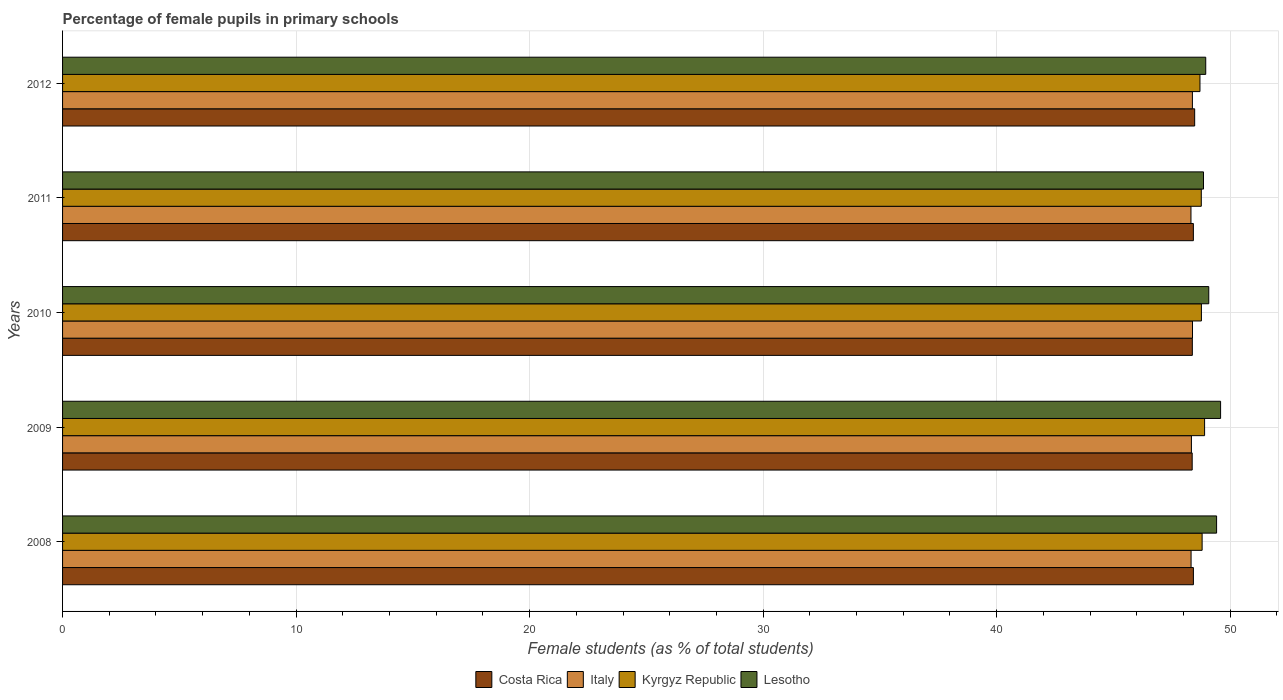How many different coloured bars are there?
Offer a terse response. 4. Are the number of bars on each tick of the Y-axis equal?
Provide a succinct answer. Yes. How many bars are there on the 2nd tick from the top?
Provide a short and direct response. 4. How many bars are there on the 3rd tick from the bottom?
Give a very brief answer. 4. What is the label of the 3rd group of bars from the top?
Your response must be concise. 2010. In how many cases, is the number of bars for a given year not equal to the number of legend labels?
Provide a succinct answer. 0. What is the percentage of female pupils in primary schools in Italy in 2011?
Keep it short and to the point. 48.32. Across all years, what is the maximum percentage of female pupils in primary schools in Costa Rica?
Provide a succinct answer. 48.48. Across all years, what is the minimum percentage of female pupils in primary schools in Lesotho?
Make the answer very short. 48.86. In which year was the percentage of female pupils in primary schools in Kyrgyz Republic maximum?
Your response must be concise. 2009. What is the total percentage of female pupils in primary schools in Lesotho in the graph?
Make the answer very short. 245.89. What is the difference between the percentage of female pupils in primary schools in Costa Rica in 2008 and that in 2011?
Your answer should be very brief. 0. What is the difference between the percentage of female pupils in primary schools in Kyrgyz Republic in 2010 and the percentage of female pupils in primary schools in Costa Rica in 2011?
Your answer should be very brief. 0.34. What is the average percentage of female pupils in primary schools in Costa Rica per year?
Ensure brevity in your answer.  48.41. In the year 2008, what is the difference between the percentage of female pupils in primary schools in Costa Rica and percentage of female pupils in primary schools in Lesotho?
Make the answer very short. -0.99. What is the ratio of the percentage of female pupils in primary schools in Italy in 2009 to that in 2012?
Offer a very short reply. 1. Is the percentage of female pupils in primary schools in Costa Rica in 2011 less than that in 2012?
Provide a short and direct response. Yes. Is the difference between the percentage of female pupils in primary schools in Costa Rica in 2009 and 2010 greater than the difference between the percentage of female pupils in primary schools in Lesotho in 2009 and 2010?
Ensure brevity in your answer.  No. What is the difference between the highest and the second highest percentage of female pupils in primary schools in Italy?
Make the answer very short. 0. What is the difference between the highest and the lowest percentage of female pupils in primary schools in Italy?
Your response must be concise. 0.07. What does the 1st bar from the bottom in 2010 represents?
Give a very brief answer. Costa Rica. Are all the bars in the graph horizontal?
Give a very brief answer. Yes. What is the difference between two consecutive major ticks on the X-axis?
Provide a succinct answer. 10. Does the graph contain any zero values?
Offer a very short reply. No. Where does the legend appear in the graph?
Your answer should be very brief. Bottom center. How are the legend labels stacked?
Offer a very short reply. Horizontal. What is the title of the graph?
Keep it short and to the point. Percentage of female pupils in primary schools. What is the label or title of the X-axis?
Ensure brevity in your answer.  Female students (as % of total students). What is the Female students (as % of total students) of Costa Rica in 2008?
Your answer should be compact. 48.42. What is the Female students (as % of total students) of Italy in 2008?
Make the answer very short. 48.32. What is the Female students (as % of total students) in Kyrgyz Republic in 2008?
Your response must be concise. 48.8. What is the Female students (as % of total students) in Lesotho in 2008?
Make the answer very short. 49.42. What is the Female students (as % of total students) of Costa Rica in 2009?
Ensure brevity in your answer.  48.37. What is the Female students (as % of total students) in Italy in 2009?
Your response must be concise. 48.34. What is the Female students (as % of total students) of Kyrgyz Republic in 2009?
Provide a succinct answer. 48.9. What is the Female students (as % of total students) of Lesotho in 2009?
Give a very brief answer. 49.59. What is the Female students (as % of total students) of Costa Rica in 2010?
Your answer should be compact. 48.38. What is the Female students (as % of total students) in Italy in 2010?
Offer a terse response. 48.38. What is the Female students (as % of total students) in Kyrgyz Republic in 2010?
Your response must be concise. 48.77. What is the Female students (as % of total students) of Lesotho in 2010?
Offer a terse response. 49.08. What is the Female students (as % of total students) of Costa Rica in 2011?
Ensure brevity in your answer.  48.42. What is the Female students (as % of total students) of Italy in 2011?
Ensure brevity in your answer.  48.32. What is the Female students (as % of total students) of Kyrgyz Republic in 2011?
Provide a succinct answer. 48.76. What is the Female students (as % of total students) of Lesotho in 2011?
Your response must be concise. 48.86. What is the Female students (as % of total students) in Costa Rica in 2012?
Make the answer very short. 48.48. What is the Female students (as % of total students) in Italy in 2012?
Keep it short and to the point. 48.38. What is the Female students (as % of total students) of Kyrgyz Republic in 2012?
Provide a succinct answer. 48.7. What is the Female students (as % of total students) of Lesotho in 2012?
Offer a very short reply. 48.95. Across all years, what is the maximum Female students (as % of total students) in Costa Rica?
Offer a very short reply. 48.48. Across all years, what is the maximum Female students (as % of total students) in Italy?
Your response must be concise. 48.38. Across all years, what is the maximum Female students (as % of total students) in Kyrgyz Republic?
Provide a succinct answer. 48.9. Across all years, what is the maximum Female students (as % of total students) of Lesotho?
Give a very brief answer. 49.59. Across all years, what is the minimum Female students (as % of total students) in Costa Rica?
Ensure brevity in your answer.  48.37. Across all years, what is the minimum Female students (as % of total students) of Italy?
Your answer should be compact. 48.32. Across all years, what is the minimum Female students (as % of total students) of Kyrgyz Republic?
Make the answer very short. 48.7. Across all years, what is the minimum Female students (as % of total students) of Lesotho?
Give a very brief answer. 48.86. What is the total Female students (as % of total students) of Costa Rica in the graph?
Offer a terse response. 242.07. What is the total Female students (as % of total students) of Italy in the graph?
Ensure brevity in your answer.  241.75. What is the total Female students (as % of total students) of Kyrgyz Republic in the graph?
Offer a very short reply. 243.93. What is the total Female students (as % of total students) in Lesotho in the graph?
Keep it short and to the point. 245.89. What is the difference between the Female students (as % of total students) of Costa Rica in 2008 and that in 2009?
Give a very brief answer. 0.05. What is the difference between the Female students (as % of total students) of Italy in 2008 and that in 2009?
Make the answer very short. -0.01. What is the difference between the Female students (as % of total students) in Kyrgyz Republic in 2008 and that in 2009?
Your response must be concise. -0.11. What is the difference between the Female students (as % of total students) of Lesotho in 2008 and that in 2009?
Your response must be concise. -0.17. What is the difference between the Female students (as % of total students) of Costa Rica in 2008 and that in 2010?
Ensure brevity in your answer.  0.05. What is the difference between the Female students (as % of total students) of Italy in 2008 and that in 2010?
Your response must be concise. -0.06. What is the difference between the Female students (as % of total students) of Kyrgyz Republic in 2008 and that in 2010?
Your answer should be compact. 0.03. What is the difference between the Female students (as % of total students) in Lesotho in 2008 and that in 2010?
Offer a terse response. 0.34. What is the difference between the Female students (as % of total students) of Costa Rica in 2008 and that in 2011?
Provide a short and direct response. 0. What is the difference between the Female students (as % of total students) of Italy in 2008 and that in 2011?
Provide a short and direct response. 0.01. What is the difference between the Female students (as % of total students) of Kyrgyz Republic in 2008 and that in 2011?
Your response must be concise. 0.04. What is the difference between the Female students (as % of total students) of Lesotho in 2008 and that in 2011?
Your answer should be compact. 0.56. What is the difference between the Female students (as % of total students) in Costa Rica in 2008 and that in 2012?
Provide a succinct answer. -0.05. What is the difference between the Female students (as % of total students) of Italy in 2008 and that in 2012?
Make the answer very short. -0.06. What is the difference between the Female students (as % of total students) in Kyrgyz Republic in 2008 and that in 2012?
Ensure brevity in your answer.  0.09. What is the difference between the Female students (as % of total students) of Lesotho in 2008 and that in 2012?
Give a very brief answer. 0.47. What is the difference between the Female students (as % of total students) in Costa Rica in 2009 and that in 2010?
Ensure brevity in your answer.  -0.01. What is the difference between the Female students (as % of total students) of Italy in 2009 and that in 2010?
Give a very brief answer. -0.05. What is the difference between the Female students (as % of total students) in Kyrgyz Republic in 2009 and that in 2010?
Your answer should be compact. 0.14. What is the difference between the Female students (as % of total students) in Lesotho in 2009 and that in 2010?
Your response must be concise. 0.51. What is the difference between the Female students (as % of total students) in Costa Rica in 2009 and that in 2011?
Your answer should be very brief. -0.05. What is the difference between the Female students (as % of total students) of Italy in 2009 and that in 2011?
Provide a short and direct response. 0.02. What is the difference between the Female students (as % of total students) in Kyrgyz Republic in 2009 and that in 2011?
Provide a short and direct response. 0.14. What is the difference between the Female students (as % of total students) of Lesotho in 2009 and that in 2011?
Keep it short and to the point. 0.73. What is the difference between the Female students (as % of total students) in Costa Rica in 2009 and that in 2012?
Offer a very short reply. -0.11. What is the difference between the Female students (as % of total students) of Italy in 2009 and that in 2012?
Make the answer very short. -0.04. What is the difference between the Female students (as % of total students) of Kyrgyz Republic in 2009 and that in 2012?
Your answer should be compact. 0.2. What is the difference between the Female students (as % of total students) in Lesotho in 2009 and that in 2012?
Your answer should be compact. 0.64. What is the difference between the Female students (as % of total students) of Costa Rica in 2010 and that in 2011?
Make the answer very short. -0.04. What is the difference between the Female students (as % of total students) in Italy in 2010 and that in 2011?
Your answer should be compact. 0.07. What is the difference between the Female students (as % of total students) in Kyrgyz Republic in 2010 and that in 2011?
Ensure brevity in your answer.  0.01. What is the difference between the Female students (as % of total students) in Lesotho in 2010 and that in 2011?
Offer a terse response. 0.23. What is the difference between the Female students (as % of total students) in Costa Rica in 2010 and that in 2012?
Offer a very short reply. -0.1. What is the difference between the Female students (as % of total students) in Italy in 2010 and that in 2012?
Your answer should be compact. 0. What is the difference between the Female students (as % of total students) in Kyrgyz Republic in 2010 and that in 2012?
Provide a succinct answer. 0.06. What is the difference between the Female students (as % of total students) of Lesotho in 2010 and that in 2012?
Keep it short and to the point. 0.13. What is the difference between the Female students (as % of total students) in Costa Rica in 2011 and that in 2012?
Provide a succinct answer. -0.06. What is the difference between the Female students (as % of total students) in Italy in 2011 and that in 2012?
Provide a succinct answer. -0.06. What is the difference between the Female students (as % of total students) of Kyrgyz Republic in 2011 and that in 2012?
Offer a terse response. 0.06. What is the difference between the Female students (as % of total students) in Lesotho in 2011 and that in 2012?
Provide a succinct answer. -0.1. What is the difference between the Female students (as % of total students) in Costa Rica in 2008 and the Female students (as % of total students) in Italy in 2009?
Your answer should be compact. 0.09. What is the difference between the Female students (as % of total students) in Costa Rica in 2008 and the Female students (as % of total students) in Kyrgyz Republic in 2009?
Ensure brevity in your answer.  -0.48. What is the difference between the Female students (as % of total students) in Costa Rica in 2008 and the Female students (as % of total students) in Lesotho in 2009?
Ensure brevity in your answer.  -1.16. What is the difference between the Female students (as % of total students) of Italy in 2008 and the Female students (as % of total students) of Kyrgyz Republic in 2009?
Ensure brevity in your answer.  -0.58. What is the difference between the Female students (as % of total students) of Italy in 2008 and the Female students (as % of total students) of Lesotho in 2009?
Your answer should be compact. -1.26. What is the difference between the Female students (as % of total students) of Kyrgyz Republic in 2008 and the Female students (as % of total students) of Lesotho in 2009?
Provide a succinct answer. -0.79. What is the difference between the Female students (as % of total students) in Costa Rica in 2008 and the Female students (as % of total students) in Italy in 2010?
Provide a short and direct response. 0.04. What is the difference between the Female students (as % of total students) in Costa Rica in 2008 and the Female students (as % of total students) in Kyrgyz Republic in 2010?
Offer a terse response. -0.34. What is the difference between the Female students (as % of total students) in Costa Rica in 2008 and the Female students (as % of total students) in Lesotho in 2010?
Keep it short and to the point. -0.66. What is the difference between the Female students (as % of total students) of Italy in 2008 and the Female students (as % of total students) of Kyrgyz Republic in 2010?
Give a very brief answer. -0.44. What is the difference between the Female students (as % of total students) in Italy in 2008 and the Female students (as % of total students) in Lesotho in 2010?
Give a very brief answer. -0.76. What is the difference between the Female students (as % of total students) in Kyrgyz Republic in 2008 and the Female students (as % of total students) in Lesotho in 2010?
Ensure brevity in your answer.  -0.28. What is the difference between the Female students (as % of total students) in Costa Rica in 2008 and the Female students (as % of total students) in Italy in 2011?
Provide a succinct answer. 0.1. What is the difference between the Female students (as % of total students) in Costa Rica in 2008 and the Female students (as % of total students) in Kyrgyz Republic in 2011?
Your response must be concise. -0.34. What is the difference between the Female students (as % of total students) of Costa Rica in 2008 and the Female students (as % of total students) of Lesotho in 2011?
Give a very brief answer. -0.43. What is the difference between the Female students (as % of total students) in Italy in 2008 and the Female students (as % of total students) in Kyrgyz Republic in 2011?
Your response must be concise. -0.44. What is the difference between the Female students (as % of total students) of Italy in 2008 and the Female students (as % of total students) of Lesotho in 2011?
Your response must be concise. -0.53. What is the difference between the Female students (as % of total students) in Kyrgyz Republic in 2008 and the Female students (as % of total students) in Lesotho in 2011?
Give a very brief answer. -0.06. What is the difference between the Female students (as % of total students) in Costa Rica in 2008 and the Female students (as % of total students) in Italy in 2012?
Provide a short and direct response. 0.04. What is the difference between the Female students (as % of total students) of Costa Rica in 2008 and the Female students (as % of total students) of Kyrgyz Republic in 2012?
Keep it short and to the point. -0.28. What is the difference between the Female students (as % of total students) in Costa Rica in 2008 and the Female students (as % of total students) in Lesotho in 2012?
Your response must be concise. -0.53. What is the difference between the Female students (as % of total students) of Italy in 2008 and the Female students (as % of total students) of Kyrgyz Republic in 2012?
Keep it short and to the point. -0.38. What is the difference between the Female students (as % of total students) in Italy in 2008 and the Female students (as % of total students) in Lesotho in 2012?
Offer a very short reply. -0.63. What is the difference between the Female students (as % of total students) in Kyrgyz Republic in 2008 and the Female students (as % of total students) in Lesotho in 2012?
Make the answer very short. -0.15. What is the difference between the Female students (as % of total students) in Costa Rica in 2009 and the Female students (as % of total students) in Italy in 2010?
Your answer should be very brief. -0.01. What is the difference between the Female students (as % of total students) of Costa Rica in 2009 and the Female students (as % of total students) of Kyrgyz Republic in 2010?
Provide a succinct answer. -0.4. What is the difference between the Female students (as % of total students) of Costa Rica in 2009 and the Female students (as % of total students) of Lesotho in 2010?
Give a very brief answer. -0.71. What is the difference between the Female students (as % of total students) of Italy in 2009 and the Female students (as % of total students) of Kyrgyz Republic in 2010?
Ensure brevity in your answer.  -0.43. What is the difference between the Female students (as % of total students) in Italy in 2009 and the Female students (as % of total students) in Lesotho in 2010?
Provide a succinct answer. -0.74. What is the difference between the Female students (as % of total students) in Kyrgyz Republic in 2009 and the Female students (as % of total students) in Lesotho in 2010?
Your response must be concise. -0.18. What is the difference between the Female students (as % of total students) in Costa Rica in 2009 and the Female students (as % of total students) in Italy in 2011?
Ensure brevity in your answer.  0.05. What is the difference between the Female students (as % of total students) in Costa Rica in 2009 and the Female students (as % of total students) in Kyrgyz Republic in 2011?
Provide a short and direct response. -0.39. What is the difference between the Female students (as % of total students) in Costa Rica in 2009 and the Female students (as % of total students) in Lesotho in 2011?
Give a very brief answer. -0.48. What is the difference between the Female students (as % of total students) of Italy in 2009 and the Female students (as % of total students) of Kyrgyz Republic in 2011?
Your answer should be very brief. -0.42. What is the difference between the Female students (as % of total students) of Italy in 2009 and the Female students (as % of total students) of Lesotho in 2011?
Your answer should be compact. -0.52. What is the difference between the Female students (as % of total students) of Kyrgyz Republic in 2009 and the Female students (as % of total students) of Lesotho in 2011?
Your answer should be very brief. 0.05. What is the difference between the Female students (as % of total students) in Costa Rica in 2009 and the Female students (as % of total students) in Italy in 2012?
Your answer should be compact. -0.01. What is the difference between the Female students (as % of total students) in Costa Rica in 2009 and the Female students (as % of total students) in Kyrgyz Republic in 2012?
Keep it short and to the point. -0.33. What is the difference between the Female students (as % of total students) in Costa Rica in 2009 and the Female students (as % of total students) in Lesotho in 2012?
Offer a terse response. -0.58. What is the difference between the Female students (as % of total students) in Italy in 2009 and the Female students (as % of total students) in Kyrgyz Republic in 2012?
Give a very brief answer. -0.37. What is the difference between the Female students (as % of total students) of Italy in 2009 and the Female students (as % of total students) of Lesotho in 2012?
Offer a very short reply. -0.61. What is the difference between the Female students (as % of total students) of Kyrgyz Republic in 2009 and the Female students (as % of total students) of Lesotho in 2012?
Your answer should be compact. -0.05. What is the difference between the Female students (as % of total students) of Costa Rica in 2010 and the Female students (as % of total students) of Italy in 2011?
Provide a succinct answer. 0.06. What is the difference between the Female students (as % of total students) of Costa Rica in 2010 and the Female students (as % of total students) of Kyrgyz Republic in 2011?
Your answer should be compact. -0.38. What is the difference between the Female students (as % of total students) of Costa Rica in 2010 and the Female students (as % of total students) of Lesotho in 2011?
Keep it short and to the point. -0.48. What is the difference between the Female students (as % of total students) in Italy in 2010 and the Female students (as % of total students) in Kyrgyz Republic in 2011?
Make the answer very short. -0.38. What is the difference between the Female students (as % of total students) in Italy in 2010 and the Female students (as % of total students) in Lesotho in 2011?
Your answer should be compact. -0.47. What is the difference between the Female students (as % of total students) in Kyrgyz Republic in 2010 and the Female students (as % of total students) in Lesotho in 2011?
Your response must be concise. -0.09. What is the difference between the Female students (as % of total students) of Costa Rica in 2010 and the Female students (as % of total students) of Italy in 2012?
Make the answer very short. -0. What is the difference between the Female students (as % of total students) in Costa Rica in 2010 and the Female students (as % of total students) in Kyrgyz Republic in 2012?
Your answer should be compact. -0.33. What is the difference between the Female students (as % of total students) of Costa Rica in 2010 and the Female students (as % of total students) of Lesotho in 2012?
Offer a terse response. -0.57. What is the difference between the Female students (as % of total students) of Italy in 2010 and the Female students (as % of total students) of Kyrgyz Republic in 2012?
Keep it short and to the point. -0.32. What is the difference between the Female students (as % of total students) in Italy in 2010 and the Female students (as % of total students) in Lesotho in 2012?
Your answer should be very brief. -0.57. What is the difference between the Female students (as % of total students) of Kyrgyz Republic in 2010 and the Female students (as % of total students) of Lesotho in 2012?
Make the answer very short. -0.18. What is the difference between the Female students (as % of total students) of Costa Rica in 2011 and the Female students (as % of total students) of Italy in 2012?
Ensure brevity in your answer.  0.04. What is the difference between the Female students (as % of total students) of Costa Rica in 2011 and the Female students (as % of total students) of Kyrgyz Republic in 2012?
Provide a short and direct response. -0.28. What is the difference between the Female students (as % of total students) in Costa Rica in 2011 and the Female students (as % of total students) in Lesotho in 2012?
Provide a succinct answer. -0.53. What is the difference between the Female students (as % of total students) in Italy in 2011 and the Female students (as % of total students) in Kyrgyz Republic in 2012?
Provide a succinct answer. -0.39. What is the difference between the Female students (as % of total students) of Italy in 2011 and the Female students (as % of total students) of Lesotho in 2012?
Provide a short and direct response. -0.63. What is the difference between the Female students (as % of total students) of Kyrgyz Republic in 2011 and the Female students (as % of total students) of Lesotho in 2012?
Give a very brief answer. -0.19. What is the average Female students (as % of total students) of Costa Rica per year?
Provide a succinct answer. 48.41. What is the average Female students (as % of total students) of Italy per year?
Your response must be concise. 48.35. What is the average Female students (as % of total students) of Kyrgyz Republic per year?
Provide a short and direct response. 48.79. What is the average Female students (as % of total students) in Lesotho per year?
Your answer should be very brief. 49.18. In the year 2008, what is the difference between the Female students (as % of total students) of Costa Rica and Female students (as % of total students) of Italy?
Ensure brevity in your answer.  0.1. In the year 2008, what is the difference between the Female students (as % of total students) of Costa Rica and Female students (as % of total students) of Kyrgyz Republic?
Your answer should be compact. -0.37. In the year 2008, what is the difference between the Female students (as % of total students) of Costa Rica and Female students (as % of total students) of Lesotho?
Provide a short and direct response. -0.99. In the year 2008, what is the difference between the Female students (as % of total students) of Italy and Female students (as % of total students) of Kyrgyz Republic?
Provide a short and direct response. -0.47. In the year 2008, what is the difference between the Female students (as % of total students) in Italy and Female students (as % of total students) in Lesotho?
Keep it short and to the point. -1.09. In the year 2008, what is the difference between the Female students (as % of total students) of Kyrgyz Republic and Female students (as % of total students) of Lesotho?
Give a very brief answer. -0.62. In the year 2009, what is the difference between the Female students (as % of total students) of Costa Rica and Female students (as % of total students) of Italy?
Make the answer very short. 0.03. In the year 2009, what is the difference between the Female students (as % of total students) of Costa Rica and Female students (as % of total students) of Kyrgyz Republic?
Offer a very short reply. -0.53. In the year 2009, what is the difference between the Female students (as % of total students) in Costa Rica and Female students (as % of total students) in Lesotho?
Provide a short and direct response. -1.22. In the year 2009, what is the difference between the Female students (as % of total students) of Italy and Female students (as % of total students) of Kyrgyz Republic?
Offer a very short reply. -0.56. In the year 2009, what is the difference between the Female students (as % of total students) in Italy and Female students (as % of total students) in Lesotho?
Give a very brief answer. -1.25. In the year 2009, what is the difference between the Female students (as % of total students) of Kyrgyz Republic and Female students (as % of total students) of Lesotho?
Provide a short and direct response. -0.69. In the year 2010, what is the difference between the Female students (as % of total students) in Costa Rica and Female students (as % of total students) in Italy?
Make the answer very short. -0.01. In the year 2010, what is the difference between the Female students (as % of total students) of Costa Rica and Female students (as % of total students) of Kyrgyz Republic?
Ensure brevity in your answer.  -0.39. In the year 2010, what is the difference between the Female students (as % of total students) in Costa Rica and Female students (as % of total students) in Lesotho?
Keep it short and to the point. -0.7. In the year 2010, what is the difference between the Female students (as % of total students) in Italy and Female students (as % of total students) in Kyrgyz Republic?
Ensure brevity in your answer.  -0.38. In the year 2010, what is the difference between the Female students (as % of total students) in Italy and Female students (as % of total students) in Lesotho?
Provide a succinct answer. -0.7. In the year 2010, what is the difference between the Female students (as % of total students) of Kyrgyz Republic and Female students (as % of total students) of Lesotho?
Offer a very short reply. -0.31. In the year 2011, what is the difference between the Female students (as % of total students) in Costa Rica and Female students (as % of total students) in Italy?
Offer a terse response. 0.1. In the year 2011, what is the difference between the Female students (as % of total students) in Costa Rica and Female students (as % of total students) in Kyrgyz Republic?
Your answer should be very brief. -0.34. In the year 2011, what is the difference between the Female students (as % of total students) in Costa Rica and Female students (as % of total students) in Lesotho?
Provide a short and direct response. -0.43. In the year 2011, what is the difference between the Female students (as % of total students) of Italy and Female students (as % of total students) of Kyrgyz Republic?
Your answer should be very brief. -0.44. In the year 2011, what is the difference between the Female students (as % of total students) of Italy and Female students (as % of total students) of Lesotho?
Your answer should be compact. -0.54. In the year 2011, what is the difference between the Female students (as % of total students) in Kyrgyz Republic and Female students (as % of total students) in Lesotho?
Provide a short and direct response. -0.09. In the year 2012, what is the difference between the Female students (as % of total students) of Costa Rica and Female students (as % of total students) of Italy?
Keep it short and to the point. 0.1. In the year 2012, what is the difference between the Female students (as % of total students) of Costa Rica and Female students (as % of total students) of Kyrgyz Republic?
Ensure brevity in your answer.  -0.23. In the year 2012, what is the difference between the Female students (as % of total students) of Costa Rica and Female students (as % of total students) of Lesotho?
Your response must be concise. -0.47. In the year 2012, what is the difference between the Female students (as % of total students) in Italy and Female students (as % of total students) in Kyrgyz Republic?
Your response must be concise. -0.32. In the year 2012, what is the difference between the Female students (as % of total students) in Italy and Female students (as % of total students) in Lesotho?
Provide a short and direct response. -0.57. In the year 2012, what is the difference between the Female students (as % of total students) in Kyrgyz Republic and Female students (as % of total students) in Lesotho?
Give a very brief answer. -0.25. What is the ratio of the Female students (as % of total students) in Kyrgyz Republic in 2008 to that in 2009?
Make the answer very short. 1. What is the ratio of the Female students (as % of total students) of Italy in 2008 to that in 2010?
Give a very brief answer. 1. What is the ratio of the Female students (as % of total students) in Kyrgyz Republic in 2008 to that in 2010?
Ensure brevity in your answer.  1. What is the ratio of the Female students (as % of total students) of Lesotho in 2008 to that in 2010?
Make the answer very short. 1.01. What is the ratio of the Female students (as % of total students) of Costa Rica in 2008 to that in 2011?
Your response must be concise. 1. What is the ratio of the Female students (as % of total students) in Kyrgyz Republic in 2008 to that in 2011?
Your answer should be very brief. 1. What is the ratio of the Female students (as % of total students) of Lesotho in 2008 to that in 2011?
Offer a very short reply. 1.01. What is the ratio of the Female students (as % of total students) of Lesotho in 2008 to that in 2012?
Offer a terse response. 1.01. What is the ratio of the Female students (as % of total students) of Costa Rica in 2009 to that in 2010?
Your answer should be compact. 1. What is the ratio of the Female students (as % of total students) in Italy in 2009 to that in 2010?
Your answer should be very brief. 1. What is the ratio of the Female students (as % of total students) of Kyrgyz Republic in 2009 to that in 2010?
Give a very brief answer. 1. What is the ratio of the Female students (as % of total students) in Lesotho in 2009 to that in 2010?
Your answer should be very brief. 1.01. What is the ratio of the Female students (as % of total students) of Costa Rica in 2009 to that in 2011?
Your answer should be very brief. 1. What is the ratio of the Female students (as % of total students) of Italy in 2009 to that in 2011?
Make the answer very short. 1. What is the ratio of the Female students (as % of total students) of Kyrgyz Republic in 2009 to that in 2011?
Ensure brevity in your answer.  1. What is the ratio of the Female students (as % of total students) in Lesotho in 2009 to that in 2011?
Offer a very short reply. 1.01. What is the ratio of the Female students (as % of total students) in Costa Rica in 2009 to that in 2012?
Offer a very short reply. 1. What is the ratio of the Female students (as % of total students) in Kyrgyz Republic in 2009 to that in 2012?
Provide a short and direct response. 1. What is the ratio of the Female students (as % of total students) in Lesotho in 2009 to that in 2012?
Ensure brevity in your answer.  1.01. What is the ratio of the Female students (as % of total students) in Costa Rica in 2010 to that in 2011?
Ensure brevity in your answer.  1. What is the ratio of the Female students (as % of total students) in Italy in 2010 to that in 2011?
Your answer should be compact. 1. What is the ratio of the Female students (as % of total students) of Lesotho in 2010 to that in 2011?
Keep it short and to the point. 1. What is the ratio of the Female students (as % of total students) in Costa Rica in 2010 to that in 2012?
Make the answer very short. 1. What is the ratio of the Female students (as % of total students) of Costa Rica in 2011 to that in 2012?
Provide a short and direct response. 1. What is the difference between the highest and the second highest Female students (as % of total students) of Costa Rica?
Ensure brevity in your answer.  0.05. What is the difference between the highest and the second highest Female students (as % of total students) in Italy?
Give a very brief answer. 0. What is the difference between the highest and the second highest Female students (as % of total students) in Kyrgyz Republic?
Your answer should be very brief. 0.11. What is the difference between the highest and the second highest Female students (as % of total students) in Lesotho?
Give a very brief answer. 0.17. What is the difference between the highest and the lowest Female students (as % of total students) of Costa Rica?
Offer a very short reply. 0.11. What is the difference between the highest and the lowest Female students (as % of total students) in Italy?
Your answer should be very brief. 0.07. What is the difference between the highest and the lowest Female students (as % of total students) in Kyrgyz Republic?
Your answer should be compact. 0.2. What is the difference between the highest and the lowest Female students (as % of total students) of Lesotho?
Your response must be concise. 0.73. 